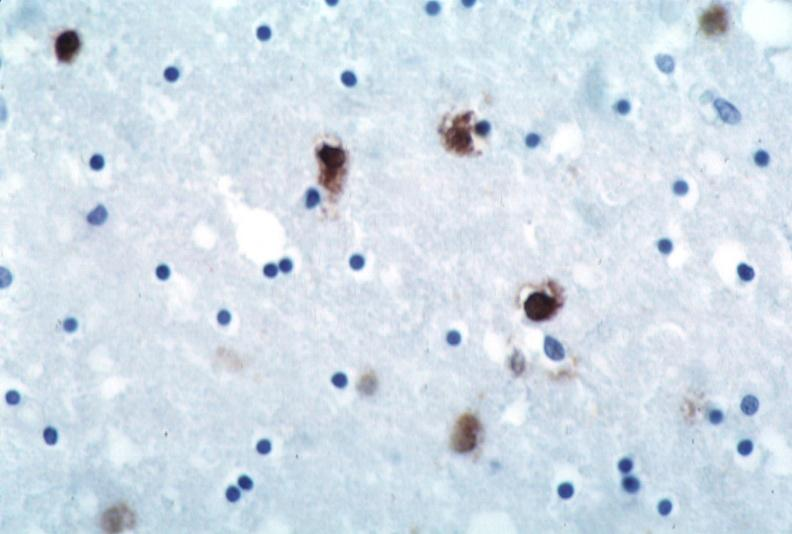s outside adrenal capsule section present?
Answer the question using a single word or phrase. No 